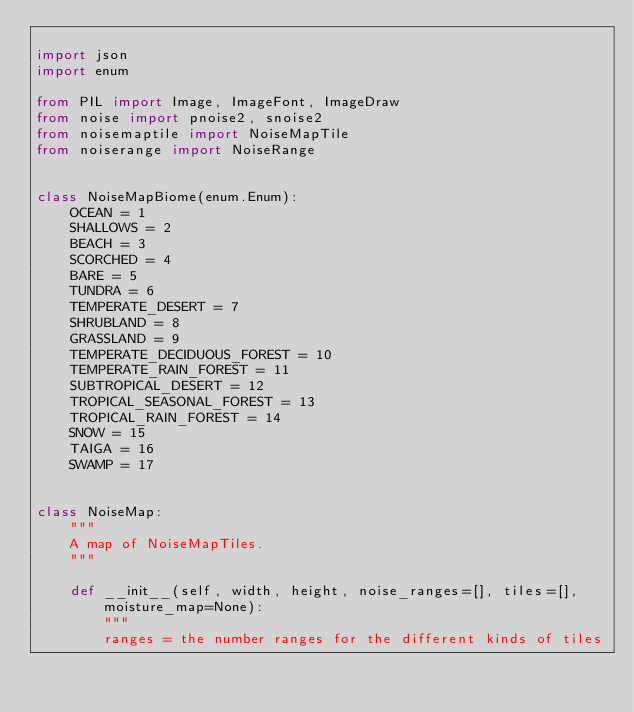<code> <loc_0><loc_0><loc_500><loc_500><_Python_>
import json
import enum

from PIL import Image, ImageFont, ImageDraw
from noise import pnoise2, snoise2
from noisemaptile import NoiseMapTile
from noiserange import NoiseRange


class NoiseMapBiome(enum.Enum):
    OCEAN = 1
    SHALLOWS = 2
    BEACH = 3
    SCORCHED = 4
    BARE = 5
    TUNDRA = 6
    TEMPERATE_DESERT = 7
    SHRUBLAND = 8
    GRASSLAND = 9
    TEMPERATE_DECIDUOUS_FOREST = 10
    TEMPERATE_RAIN_FOREST = 11
    SUBTROPICAL_DESERT = 12
    TROPICAL_SEASONAL_FOREST = 13
    TROPICAL_RAIN_FOREST = 14
    SNOW = 15
    TAIGA = 16
    SWAMP = 17


class NoiseMap:
    """
    A map of NoiseMapTiles.
    """

    def __init__(self, width, height, noise_ranges=[], tiles=[], moisture_map=None):
        """
        ranges = the number ranges for the different kinds of tiles</code> 